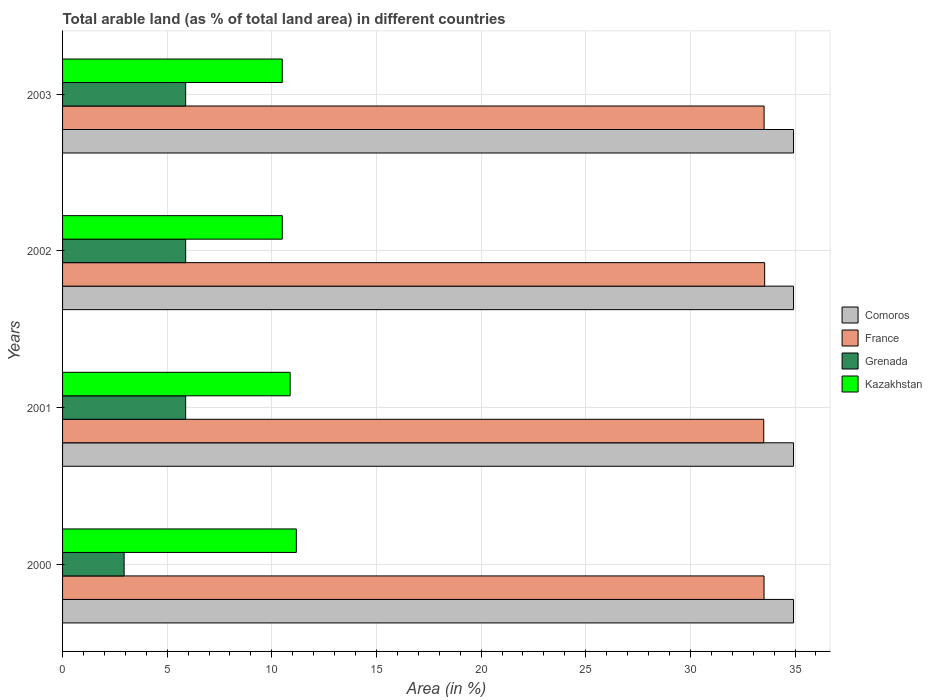How many groups of bars are there?
Keep it short and to the point. 4. How many bars are there on the 3rd tick from the top?
Keep it short and to the point. 4. What is the label of the 3rd group of bars from the top?
Offer a terse response. 2001. What is the percentage of arable land in Kazakhstan in 2000?
Keep it short and to the point. 11.17. Across all years, what is the maximum percentage of arable land in France?
Provide a succinct answer. 33.55. Across all years, what is the minimum percentage of arable land in France?
Offer a terse response. 33.51. In which year was the percentage of arable land in Grenada maximum?
Offer a very short reply. 2001. In which year was the percentage of arable land in Kazakhstan minimum?
Offer a terse response. 2003. What is the total percentage of arable land in Comoros in the graph?
Make the answer very short. 139.71. What is the difference between the percentage of arable land in Kazakhstan in 2001 and that in 2002?
Offer a terse response. 0.38. What is the difference between the percentage of arable land in Comoros in 2000 and the percentage of arable land in France in 2001?
Give a very brief answer. 1.42. What is the average percentage of arable land in Grenada per year?
Make the answer very short. 5.15. In the year 2000, what is the difference between the percentage of arable land in Grenada and percentage of arable land in France?
Make the answer very short. -30.58. What is the ratio of the percentage of arable land in France in 2000 to that in 2002?
Your answer should be very brief. 1. Is the percentage of arable land in Grenada in 2000 less than that in 2002?
Your answer should be compact. Yes. Is the difference between the percentage of arable land in Grenada in 2002 and 2003 greater than the difference between the percentage of arable land in France in 2002 and 2003?
Your answer should be very brief. No. What is the difference between the highest and the second highest percentage of arable land in France?
Offer a very short reply. 0.03. What is the difference between the highest and the lowest percentage of arable land in Kazakhstan?
Give a very brief answer. 0.67. Is it the case that in every year, the sum of the percentage of arable land in Grenada and percentage of arable land in France is greater than the sum of percentage of arable land in Comoros and percentage of arable land in Kazakhstan?
Your response must be concise. No. What does the 3rd bar from the top in 2001 represents?
Offer a very short reply. France. What does the 4th bar from the bottom in 2003 represents?
Give a very brief answer. Kazakhstan. How many bars are there?
Make the answer very short. 16. Are all the bars in the graph horizontal?
Ensure brevity in your answer.  Yes. Does the graph contain any zero values?
Your response must be concise. No. How many legend labels are there?
Your response must be concise. 4. How are the legend labels stacked?
Offer a terse response. Vertical. What is the title of the graph?
Your response must be concise. Total arable land (as % of total land area) in different countries. Does "Angola" appear as one of the legend labels in the graph?
Make the answer very short. No. What is the label or title of the X-axis?
Give a very brief answer. Area (in %). What is the Area (in %) in Comoros in 2000?
Your answer should be very brief. 34.93. What is the Area (in %) of France in 2000?
Make the answer very short. 33.52. What is the Area (in %) in Grenada in 2000?
Your answer should be compact. 2.94. What is the Area (in %) in Kazakhstan in 2000?
Your response must be concise. 11.17. What is the Area (in %) of Comoros in 2001?
Offer a very short reply. 34.93. What is the Area (in %) in France in 2001?
Your response must be concise. 33.51. What is the Area (in %) in Grenada in 2001?
Provide a short and direct response. 5.88. What is the Area (in %) in Kazakhstan in 2001?
Give a very brief answer. 10.88. What is the Area (in %) in Comoros in 2002?
Give a very brief answer. 34.93. What is the Area (in %) of France in 2002?
Your answer should be very brief. 33.55. What is the Area (in %) of Grenada in 2002?
Your answer should be very brief. 5.88. What is the Area (in %) in Kazakhstan in 2002?
Provide a short and direct response. 10.5. What is the Area (in %) of Comoros in 2003?
Your response must be concise. 34.93. What is the Area (in %) of France in 2003?
Your answer should be very brief. 33.52. What is the Area (in %) in Grenada in 2003?
Offer a very short reply. 5.88. What is the Area (in %) in Kazakhstan in 2003?
Provide a succinct answer. 10.5. Across all years, what is the maximum Area (in %) in Comoros?
Offer a very short reply. 34.93. Across all years, what is the maximum Area (in %) in France?
Ensure brevity in your answer.  33.55. Across all years, what is the maximum Area (in %) of Grenada?
Offer a terse response. 5.88. Across all years, what is the maximum Area (in %) of Kazakhstan?
Your answer should be compact. 11.17. Across all years, what is the minimum Area (in %) of Comoros?
Give a very brief answer. 34.93. Across all years, what is the minimum Area (in %) in France?
Your response must be concise. 33.51. Across all years, what is the minimum Area (in %) of Grenada?
Your answer should be very brief. 2.94. Across all years, what is the minimum Area (in %) of Kazakhstan?
Offer a terse response. 10.5. What is the total Area (in %) of Comoros in the graph?
Offer a very short reply. 139.71. What is the total Area (in %) of France in the graph?
Your answer should be compact. 134.09. What is the total Area (in %) in Grenada in the graph?
Provide a short and direct response. 20.59. What is the total Area (in %) in Kazakhstan in the graph?
Keep it short and to the point. 43.05. What is the difference between the Area (in %) in Comoros in 2000 and that in 2001?
Offer a very short reply. 0. What is the difference between the Area (in %) of France in 2000 and that in 2001?
Offer a very short reply. 0.01. What is the difference between the Area (in %) in Grenada in 2000 and that in 2001?
Your answer should be compact. -2.94. What is the difference between the Area (in %) of Kazakhstan in 2000 and that in 2001?
Keep it short and to the point. 0.3. What is the difference between the Area (in %) in Comoros in 2000 and that in 2002?
Offer a very short reply. 0. What is the difference between the Area (in %) in France in 2000 and that in 2002?
Offer a terse response. -0.03. What is the difference between the Area (in %) of Grenada in 2000 and that in 2002?
Ensure brevity in your answer.  -2.94. What is the difference between the Area (in %) of Kazakhstan in 2000 and that in 2002?
Your response must be concise. 0.67. What is the difference between the Area (in %) in Comoros in 2000 and that in 2003?
Offer a very short reply. 0. What is the difference between the Area (in %) in France in 2000 and that in 2003?
Your answer should be very brief. -0. What is the difference between the Area (in %) in Grenada in 2000 and that in 2003?
Your answer should be very brief. -2.94. What is the difference between the Area (in %) of Kazakhstan in 2000 and that in 2003?
Ensure brevity in your answer.  0.67. What is the difference between the Area (in %) in France in 2001 and that in 2002?
Provide a succinct answer. -0.04. What is the difference between the Area (in %) of Grenada in 2001 and that in 2002?
Provide a short and direct response. 0. What is the difference between the Area (in %) of Kazakhstan in 2001 and that in 2002?
Offer a terse response. 0.38. What is the difference between the Area (in %) of Comoros in 2001 and that in 2003?
Give a very brief answer. 0. What is the difference between the Area (in %) in France in 2001 and that in 2003?
Provide a succinct answer. -0.02. What is the difference between the Area (in %) in Kazakhstan in 2001 and that in 2003?
Make the answer very short. 0.38. What is the difference between the Area (in %) in Comoros in 2002 and that in 2003?
Provide a succinct answer. 0. What is the difference between the Area (in %) of France in 2002 and that in 2003?
Offer a terse response. 0.03. What is the difference between the Area (in %) of Kazakhstan in 2002 and that in 2003?
Your answer should be very brief. 0. What is the difference between the Area (in %) in Comoros in 2000 and the Area (in %) in France in 2001?
Ensure brevity in your answer.  1.42. What is the difference between the Area (in %) in Comoros in 2000 and the Area (in %) in Grenada in 2001?
Provide a succinct answer. 29.05. What is the difference between the Area (in %) of Comoros in 2000 and the Area (in %) of Kazakhstan in 2001?
Ensure brevity in your answer.  24.05. What is the difference between the Area (in %) in France in 2000 and the Area (in %) in Grenada in 2001?
Offer a very short reply. 27.64. What is the difference between the Area (in %) in France in 2000 and the Area (in %) in Kazakhstan in 2001?
Your answer should be compact. 22.64. What is the difference between the Area (in %) in Grenada in 2000 and the Area (in %) in Kazakhstan in 2001?
Your response must be concise. -7.93. What is the difference between the Area (in %) in Comoros in 2000 and the Area (in %) in France in 2002?
Make the answer very short. 1.38. What is the difference between the Area (in %) in Comoros in 2000 and the Area (in %) in Grenada in 2002?
Your answer should be very brief. 29.05. What is the difference between the Area (in %) of Comoros in 2000 and the Area (in %) of Kazakhstan in 2002?
Provide a short and direct response. 24.43. What is the difference between the Area (in %) of France in 2000 and the Area (in %) of Grenada in 2002?
Provide a succinct answer. 27.64. What is the difference between the Area (in %) in France in 2000 and the Area (in %) in Kazakhstan in 2002?
Your answer should be very brief. 23.02. What is the difference between the Area (in %) in Grenada in 2000 and the Area (in %) in Kazakhstan in 2002?
Ensure brevity in your answer.  -7.56. What is the difference between the Area (in %) of Comoros in 2000 and the Area (in %) of France in 2003?
Provide a short and direct response. 1.41. What is the difference between the Area (in %) of Comoros in 2000 and the Area (in %) of Grenada in 2003?
Make the answer very short. 29.05. What is the difference between the Area (in %) of Comoros in 2000 and the Area (in %) of Kazakhstan in 2003?
Offer a very short reply. 24.43. What is the difference between the Area (in %) of France in 2000 and the Area (in %) of Grenada in 2003?
Your answer should be very brief. 27.64. What is the difference between the Area (in %) of France in 2000 and the Area (in %) of Kazakhstan in 2003?
Keep it short and to the point. 23.02. What is the difference between the Area (in %) of Grenada in 2000 and the Area (in %) of Kazakhstan in 2003?
Provide a succinct answer. -7.56. What is the difference between the Area (in %) in Comoros in 2001 and the Area (in %) in France in 2002?
Provide a succinct answer. 1.38. What is the difference between the Area (in %) in Comoros in 2001 and the Area (in %) in Grenada in 2002?
Your answer should be very brief. 29.05. What is the difference between the Area (in %) of Comoros in 2001 and the Area (in %) of Kazakhstan in 2002?
Offer a terse response. 24.43. What is the difference between the Area (in %) in France in 2001 and the Area (in %) in Grenada in 2002?
Provide a succinct answer. 27.62. What is the difference between the Area (in %) of France in 2001 and the Area (in %) of Kazakhstan in 2002?
Your answer should be compact. 23.01. What is the difference between the Area (in %) of Grenada in 2001 and the Area (in %) of Kazakhstan in 2002?
Provide a succinct answer. -4.62. What is the difference between the Area (in %) of Comoros in 2001 and the Area (in %) of France in 2003?
Ensure brevity in your answer.  1.41. What is the difference between the Area (in %) in Comoros in 2001 and the Area (in %) in Grenada in 2003?
Provide a succinct answer. 29.05. What is the difference between the Area (in %) in Comoros in 2001 and the Area (in %) in Kazakhstan in 2003?
Give a very brief answer. 24.43. What is the difference between the Area (in %) of France in 2001 and the Area (in %) of Grenada in 2003?
Provide a succinct answer. 27.62. What is the difference between the Area (in %) of France in 2001 and the Area (in %) of Kazakhstan in 2003?
Your answer should be very brief. 23.01. What is the difference between the Area (in %) in Grenada in 2001 and the Area (in %) in Kazakhstan in 2003?
Give a very brief answer. -4.62. What is the difference between the Area (in %) in Comoros in 2002 and the Area (in %) in France in 2003?
Ensure brevity in your answer.  1.41. What is the difference between the Area (in %) of Comoros in 2002 and the Area (in %) of Grenada in 2003?
Keep it short and to the point. 29.05. What is the difference between the Area (in %) in Comoros in 2002 and the Area (in %) in Kazakhstan in 2003?
Give a very brief answer. 24.43. What is the difference between the Area (in %) in France in 2002 and the Area (in %) in Grenada in 2003?
Offer a very short reply. 27.67. What is the difference between the Area (in %) in France in 2002 and the Area (in %) in Kazakhstan in 2003?
Offer a terse response. 23.05. What is the difference between the Area (in %) in Grenada in 2002 and the Area (in %) in Kazakhstan in 2003?
Ensure brevity in your answer.  -4.62. What is the average Area (in %) in Comoros per year?
Give a very brief answer. 34.93. What is the average Area (in %) in France per year?
Your answer should be very brief. 33.52. What is the average Area (in %) in Grenada per year?
Offer a very short reply. 5.15. What is the average Area (in %) in Kazakhstan per year?
Your answer should be compact. 10.76. In the year 2000, what is the difference between the Area (in %) in Comoros and Area (in %) in France?
Offer a very short reply. 1.41. In the year 2000, what is the difference between the Area (in %) of Comoros and Area (in %) of Grenada?
Offer a very short reply. 31.99. In the year 2000, what is the difference between the Area (in %) in Comoros and Area (in %) in Kazakhstan?
Ensure brevity in your answer.  23.76. In the year 2000, what is the difference between the Area (in %) of France and Area (in %) of Grenada?
Make the answer very short. 30.58. In the year 2000, what is the difference between the Area (in %) in France and Area (in %) in Kazakhstan?
Your answer should be compact. 22.35. In the year 2000, what is the difference between the Area (in %) in Grenada and Area (in %) in Kazakhstan?
Give a very brief answer. -8.23. In the year 2001, what is the difference between the Area (in %) of Comoros and Area (in %) of France?
Keep it short and to the point. 1.42. In the year 2001, what is the difference between the Area (in %) in Comoros and Area (in %) in Grenada?
Ensure brevity in your answer.  29.05. In the year 2001, what is the difference between the Area (in %) in Comoros and Area (in %) in Kazakhstan?
Give a very brief answer. 24.05. In the year 2001, what is the difference between the Area (in %) of France and Area (in %) of Grenada?
Make the answer very short. 27.62. In the year 2001, what is the difference between the Area (in %) in France and Area (in %) in Kazakhstan?
Keep it short and to the point. 22.63. In the year 2001, what is the difference between the Area (in %) of Grenada and Area (in %) of Kazakhstan?
Keep it short and to the point. -4.99. In the year 2002, what is the difference between the Area (in %) in Comoros and Area (in %) in France?
Make the answer very short. 1.38. In the year 2002, what is the difference between the Area (in %) of Comoros and Area (in %) of Grenada?
Give a very brief answer. 29.05. In the year 2002, what is the difference between the Area (in %) in Comoros and Area (in %) in Kazakhstan?
Your response must be concise. 24.43. In the year 2002, what is the difference between the Area (in %) of France and Area (in %) of Grenada?
Your response must be concise. 27.67. In the year 2002, what is the difference between the Area (in %) of France and Area (in %) of Kazakhstan?
Keep it short and to the point. 23.05. In the year 2002, what is the difference between the Area (in %) of Grenada and Area (in %) of Kazakhstan?
Make the answer very short. -4.62. In the year 2003, what is the difference between the Area (in %) in Comoros and Area (in %) in France?
Your answer should be compact. 1.41. In the year 2003, what is the difference between the Area (in %) of Comoros and Area (in %) of Grenada?
Offer a terse response. 29.05. In the year 2003, what is the difference between the Area (in %) of Comoros and Area (in %) of Kazakhstan?
Your answer should be compact. 24.43. In the year 2003, what is the difference between the Area (in %) of France and Area (in %) of Grenada?
Make the answer very short. 27.64. In the year 2003, what is the difference between the Area (in %) in France and Area (in %) in Kazakhstan?
Make the answer very short. 23.02. In the year 2003, what is the difference between the Area (in %) in Grenada and Area (in %) in Kazakhstan?
Your answer should be compact. -4.62. What is the ratio of the Area (in %) of Grenada in 2000 to that in 2001?
Offer a terse response. 0.5. What is the ratio of the Area (in %) of Kazakhstan in 2000 to that in 2001?
Give a very brief answer. 1.03. What is the ratio of the Area (in %) of France in 2000 to that in 2002?
Your answer should be very brief. 1. What is the ratio of the Area (in %) in Kazakhstan in 2000 to that in 2002?
Give a very brief answer. 1.06. What is the ratio of the Area (in %) of Comoros in 2000 to that in 2003?
Provide a succinct answer. 1. What is the ratio of the Area (in %) in Kazakhstan in 2000 to that in 2003?
Provide a short and direct response. 1.06. What is the ratio of the Area (in %) of Grenada in 2001 to that in 2002?
Keep it short and to the point. 1. What is the ratio of the Area (in %) of Kazakhstan in 2001 to that in 2002?
Give a very brief answer. 1.04. What is the ratio of the Area (in %) in Grenada in 2001 to that in 2003?
Keep it short and to the point. 1. What is the ratio of the Area (in %) in Kazakhstan in 2001 to that in 2003?
Your response must be concise. 1.04. What is the ratio of the Area (in %) in Grenada in 2002 to that in 2003?
Your answer should be compact. 1. What is the ratio of the Area (in %) in Kazakhstan in 2002 to that in 2003?
Ensure brevity in your answer.  1. What is the difference between the highest and the second highest Area (in %) in Comoros?
Keep it short and to the point. 0. What is the difference between the highest and the second highest Area (in %) of France?
Provide a succinct answer. 0.03. What is the difference between the highest and the second highest Area (in %) of Kazakhstan?
Keep it short and to the point. 0.3. What is the difference between the highest and the lowest Area (in %) of Comoros?
Give a very brief answer. 0. What is the difference between the highest and the lowest Area (in %) of France?
Provide a succinct answer. 0.04. What is the difference between the highest and the lowest Area (in %) in Grenada?
Offer a very short reply. 2.94. What is the difference between the highest and the lowest Area (in %) in Kazakhstan?
Make the answer very short. 0.67. 